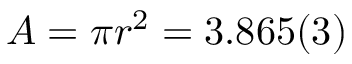Convert formula to latex. <formula><loc_0><loc_0><loc_500><loc_500>A = \pi r ^ { 2 } = 3 . 8 6 5 ( 3 )</formula> 